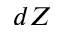<formula> <loc_0><loc_0><loc_500><loc_500>d Z</formula> 